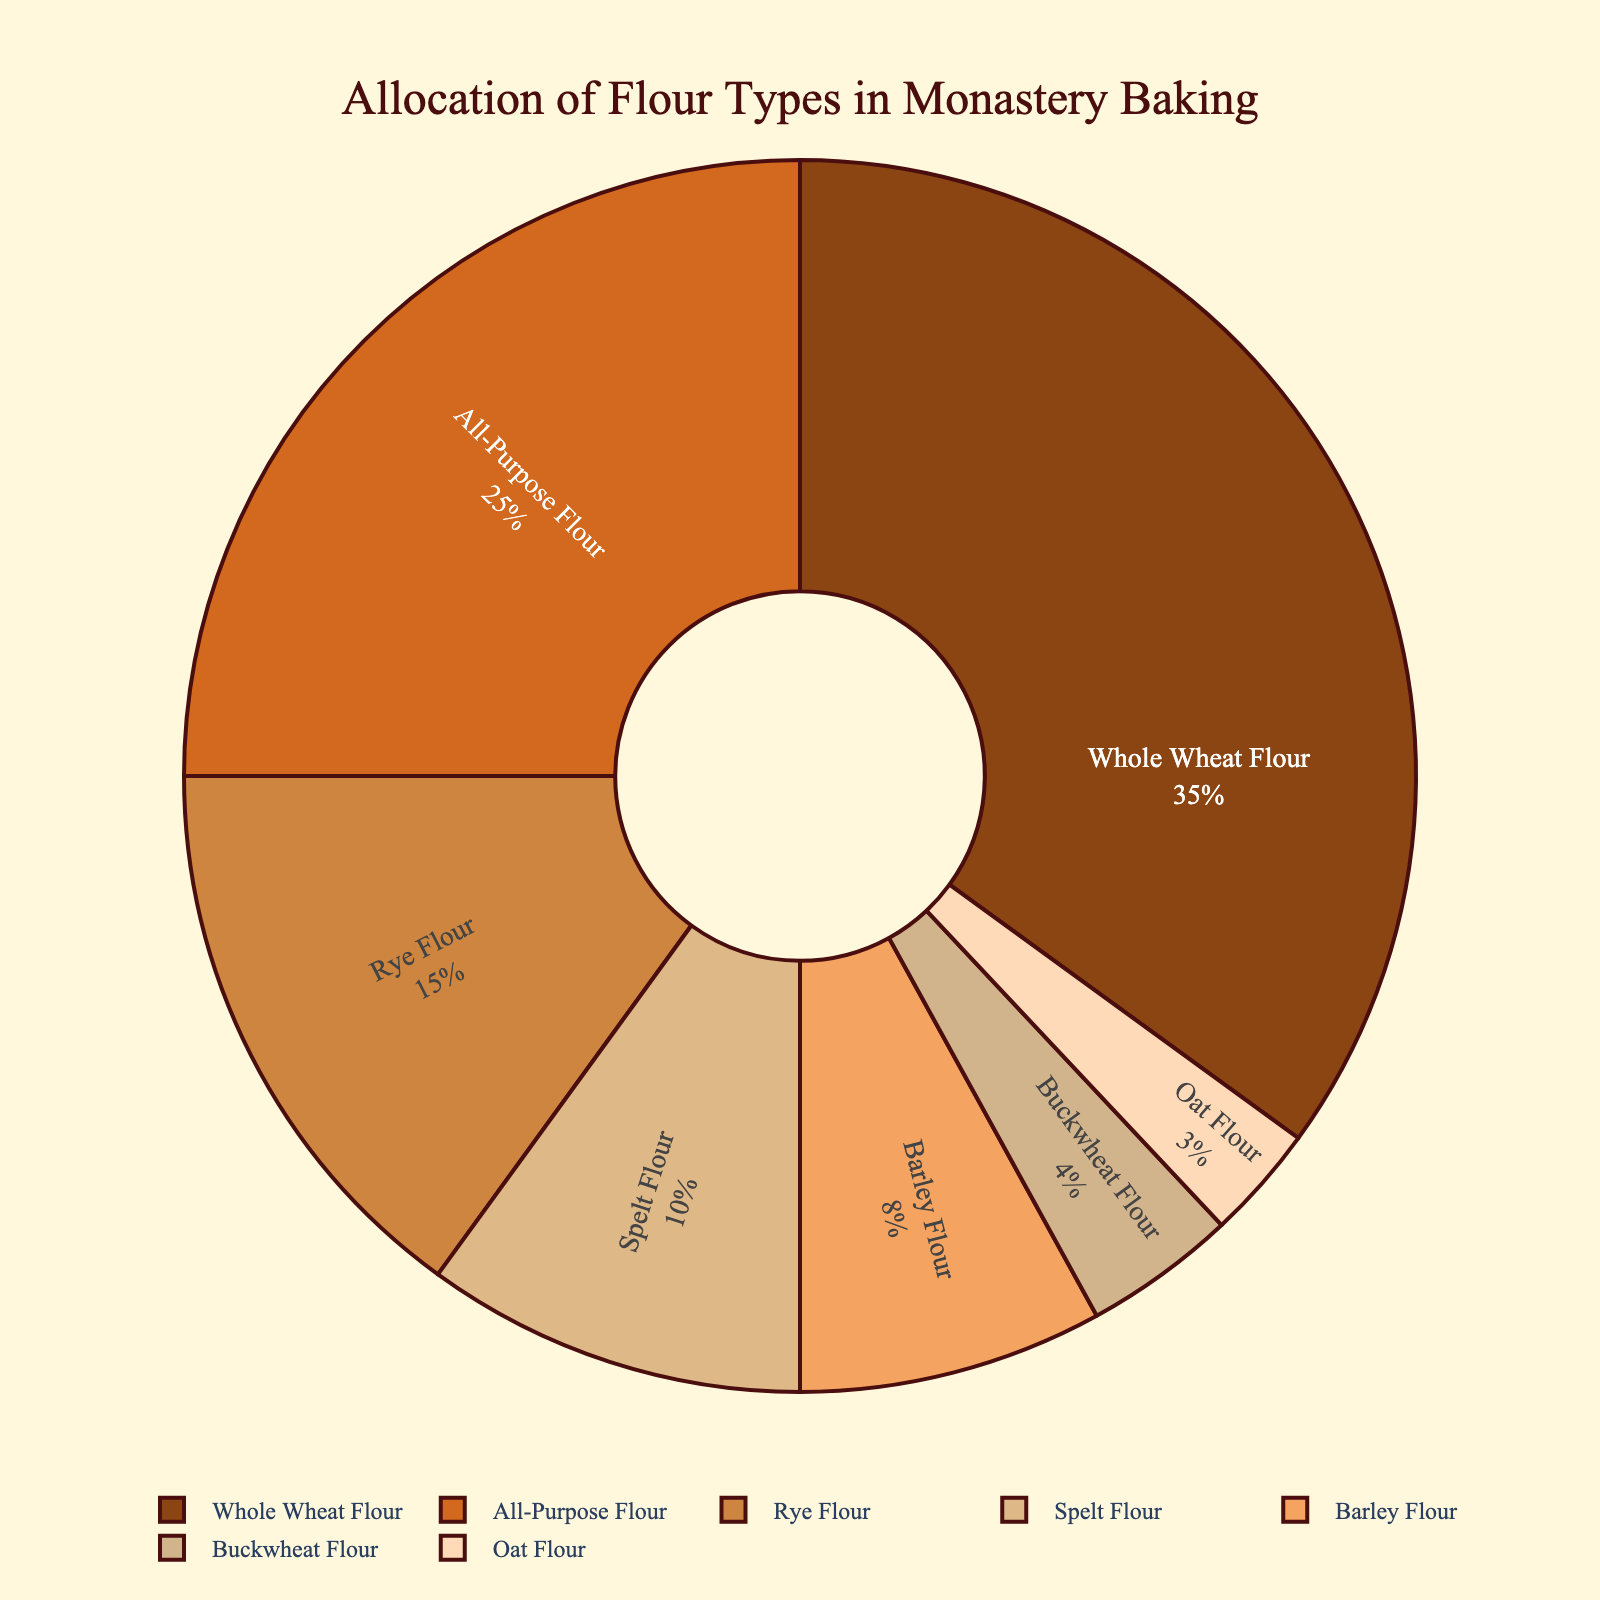What percentage of the flour is Whole Wheat Flour? Whole Wheat Flour is directly depicted as having a 35% share in the pie chart.
Answer: 35% How much more whole wheat flour is used compared to oat flour? As seen in the chart, Whole Wheat Flour is 35% and Oat Flour is 3%. The difference is 35% - 3%.
Answer: 32% What is the sum of the percentages of All-Purpose Flour and Rye Flour? All-Purpose Flour is 25% and Rye Flour is 15%. Adding them together gives 25% + 15%.
Answer: 40% Which flour is used the least in traditional monastery baking, and what color is its segment? The segment for Oat Flour represents 3%, which is the smallest percentage. The color of this segment is depicted as light peach.
Answer: Oat Flour, light peach Which flour types combined constitute more than half of the total flour allocation? Whole Wheat Flour is 35%, and All-Purpose Flour is 25%. Together, they make up 35% + 25%, which is 60%, more than half.
Answer: Whole Wheat Flour and All-Purpose Flour What two flour types have a combined allocation that is equal to the allocation of Whole Wheat Flour? Rye Flour and Spelt Flour together are 15% + 10%, which equals 25%. When combined with Barley Flour's allocation of 8%, they sum to 33%. To find two flour types we sum Barley and Buckwheat (8% + 4%): 25% + 12% + 33% equal Whole Wheat Flour (35%)
Answer: Rye Flour and Spelt Flour (25%) What is the visual placement and size relation of Spelt Flour compared to Buckwheat Flour in the chart? Spelt Flour occupies a larger segment (10%) than Buckwheat Flour (4%). The Spelt Flour slice is less than three times larger and positioned adjacent to other smaller slices towards the right of Whole Wheat Flour.
Answer: Spelt Flour is larger and to the right What color represents the largest flour type allocation, and what is the percent allocation? The largest flour type is Whole Wheat Flour, shown with a dark brown segment occupying 35%.
Answer: Dark brown, 35% How does the allocation of Barley Flour compare to the combined total of Buckwheat Flour and Oat Flour? Barley Flour is allocated at 8%, while Buckwheat Flour and Oat Flour together make up 4% + 3%, totaling 7%.
Answer: Barley Flour is 1% more How is the legend of the chart visually represented, and what is its placement? The legend uses the same colors as the pie segments and lists flour types horizontally below the chart. It is centered at the bottom of the figure.
Answer: Horizontal, centered below 